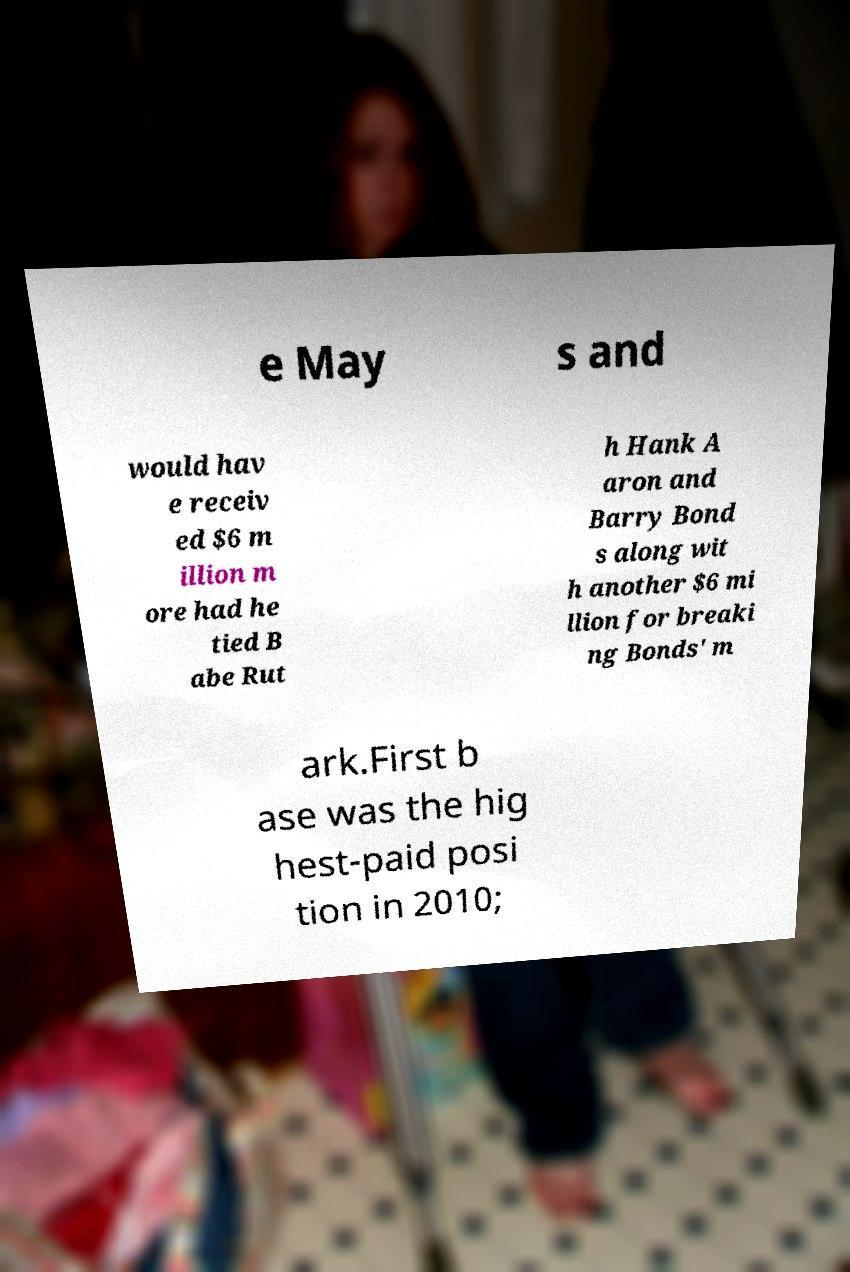Could you assist in decoding the text presented in this image and type it out clearly? e May s and would hav e receiv ed $6 m illion m ore had he tied B abe Rut h Hank A aron and Barry Bond s along wit h another $6 mi llion for breaki ng Bonds' m ark.First b ase was the hig hest-paid posi tion in 2010; 